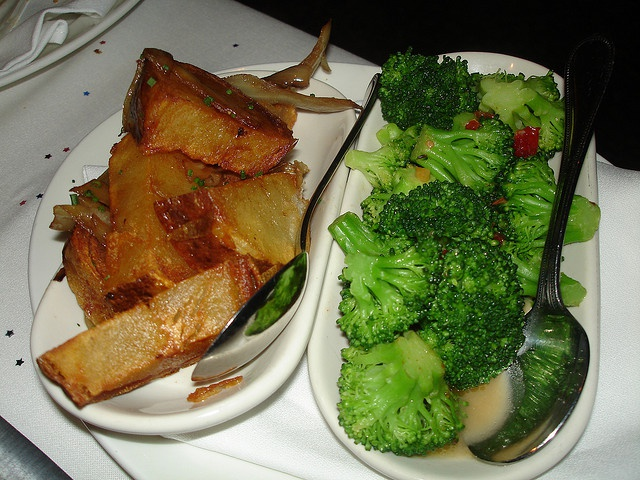Describe the objects in this image and their specific colors. I can see bowl in darkgreen, maroon, olive, and darkgray tones, broccoli in darkgreen and green tones, spoon in darkgreen, black, and gray tones, spoon in darkgreen, black, darkgray, and gray tones, and broccoli in darkgreen, olive, and green tones in this image. 